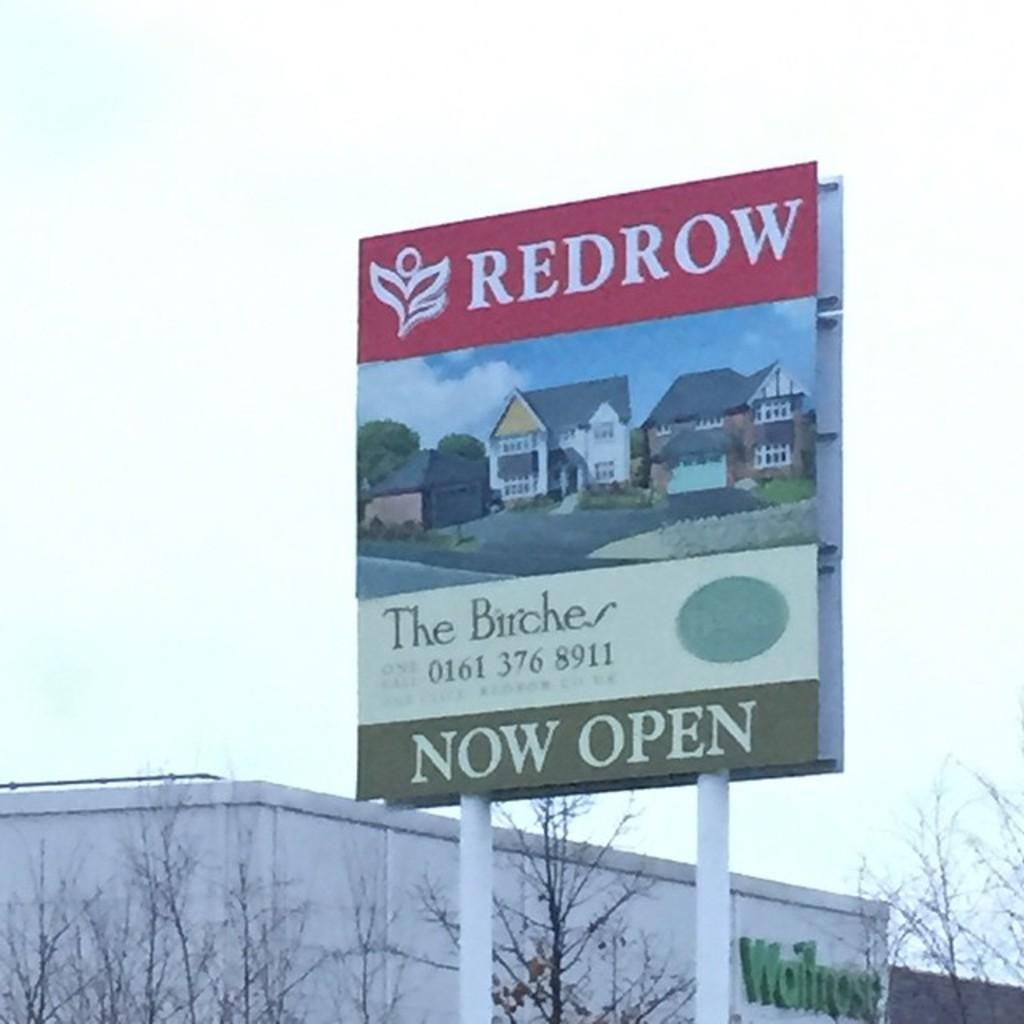<image>
Relay a brief, clear account of the picture shown. An artists rendering of homes on a sign advertising for The Birches residential development. 